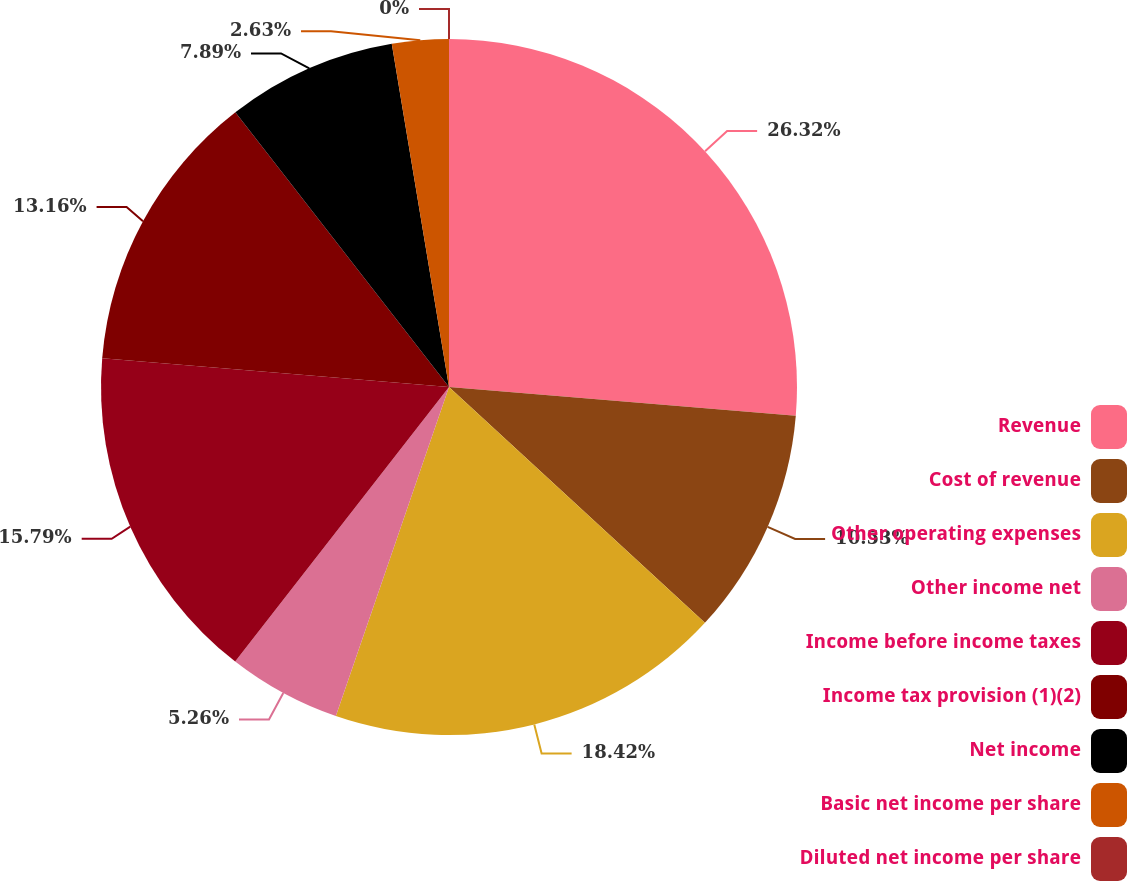Convert chart to OTSL. <chart><loc_0><loc_0><loc_500><loc_500><pie_chart><fcel>Revenue<fcel>Cost of revenue<fcel>Other operating expenses<fcel>Other income net<fcel>Income before income taxes<fcel>Income tax provision (1)(2)<fcel>Net income<fcel>Basic net income per share<fcel>Diluted net income per share<nl><fcel>26.32%<fcel>10.53%<fcel>18.42%<fcel>5.26%<fcel>15.79%<fcel>13.16%<fcel>7.89%<fcel>2.63%<fcel>0.0%<nl></chart> 